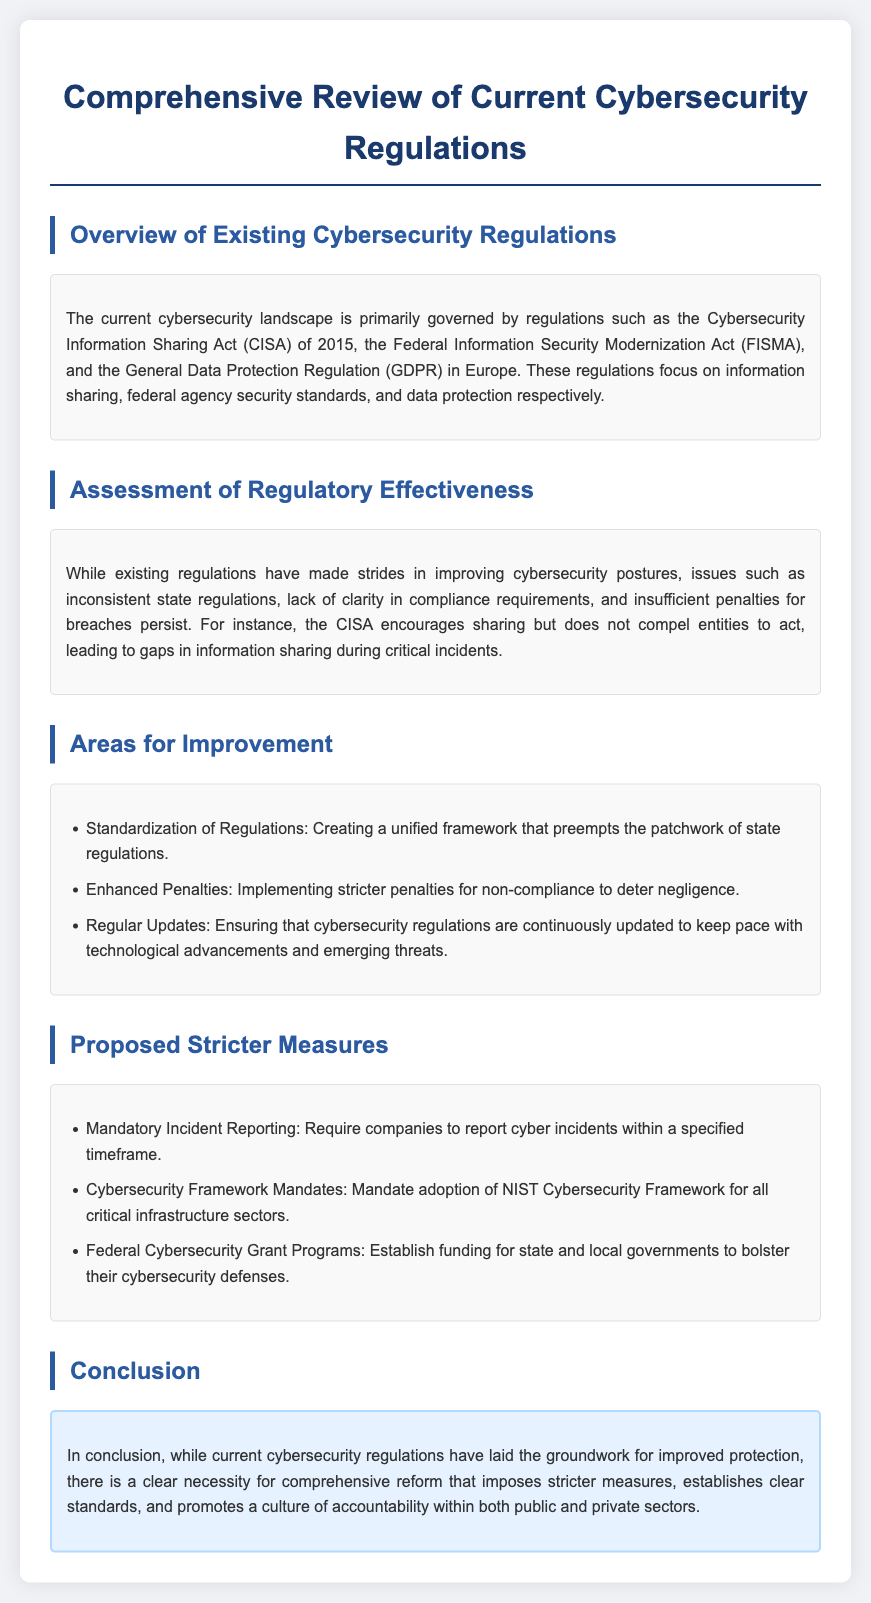What are the names of existing cybersecurity regulations? The existing cybersecurity regulations mentioned in the document are the Cybersecurity Information Sharing Act (CISA), the Federal Information Security Modernization Act (FISMA), and the General Data Protection Regulation (GDPR).
Answer: CISA, FISMA, GDPR What is a primary issue with current cybersecurity regulations? The document states that a primary issue is the inconsistent state regulations.
Answer: Inconsistent state regulations What is a proposed stricter measure related to incident reporting? The document proposes mandatory incident reporting that requires companies to report cyber incidents within a specified timeframe.
Answer: Mandatory Incident Reporting Which cybersecurity framework is suggested for adoption in critical infrastructure? The document suggests mandating the adoption of the NIST Cybersecurity Framework for all critical infrastructure sectors.
Answer: NIST Cybersecurity Framework What is one of the areas for improvement in cybersecurity regulations? One area for improvement mentioned is the standardization of regulations.
Answer: Standardization of Regulations How does the document conclude regarding current cybersecurity regulations? The conclusion indicates there is a clear necessity for comprehensive reform that imposes stricter measures.
Answer: Comprehensive reform needed What type of grants does the document propose to establish for cybersecurity? The document proposes establishing federal cybersecurity grant programs.
Answer: Federal Cybersecurity Grant Programs What is the purpose of the proposed stricter penalties? The purpose of the proposed stricter penalties is to deter negligence.
Answer: Deter negligence 